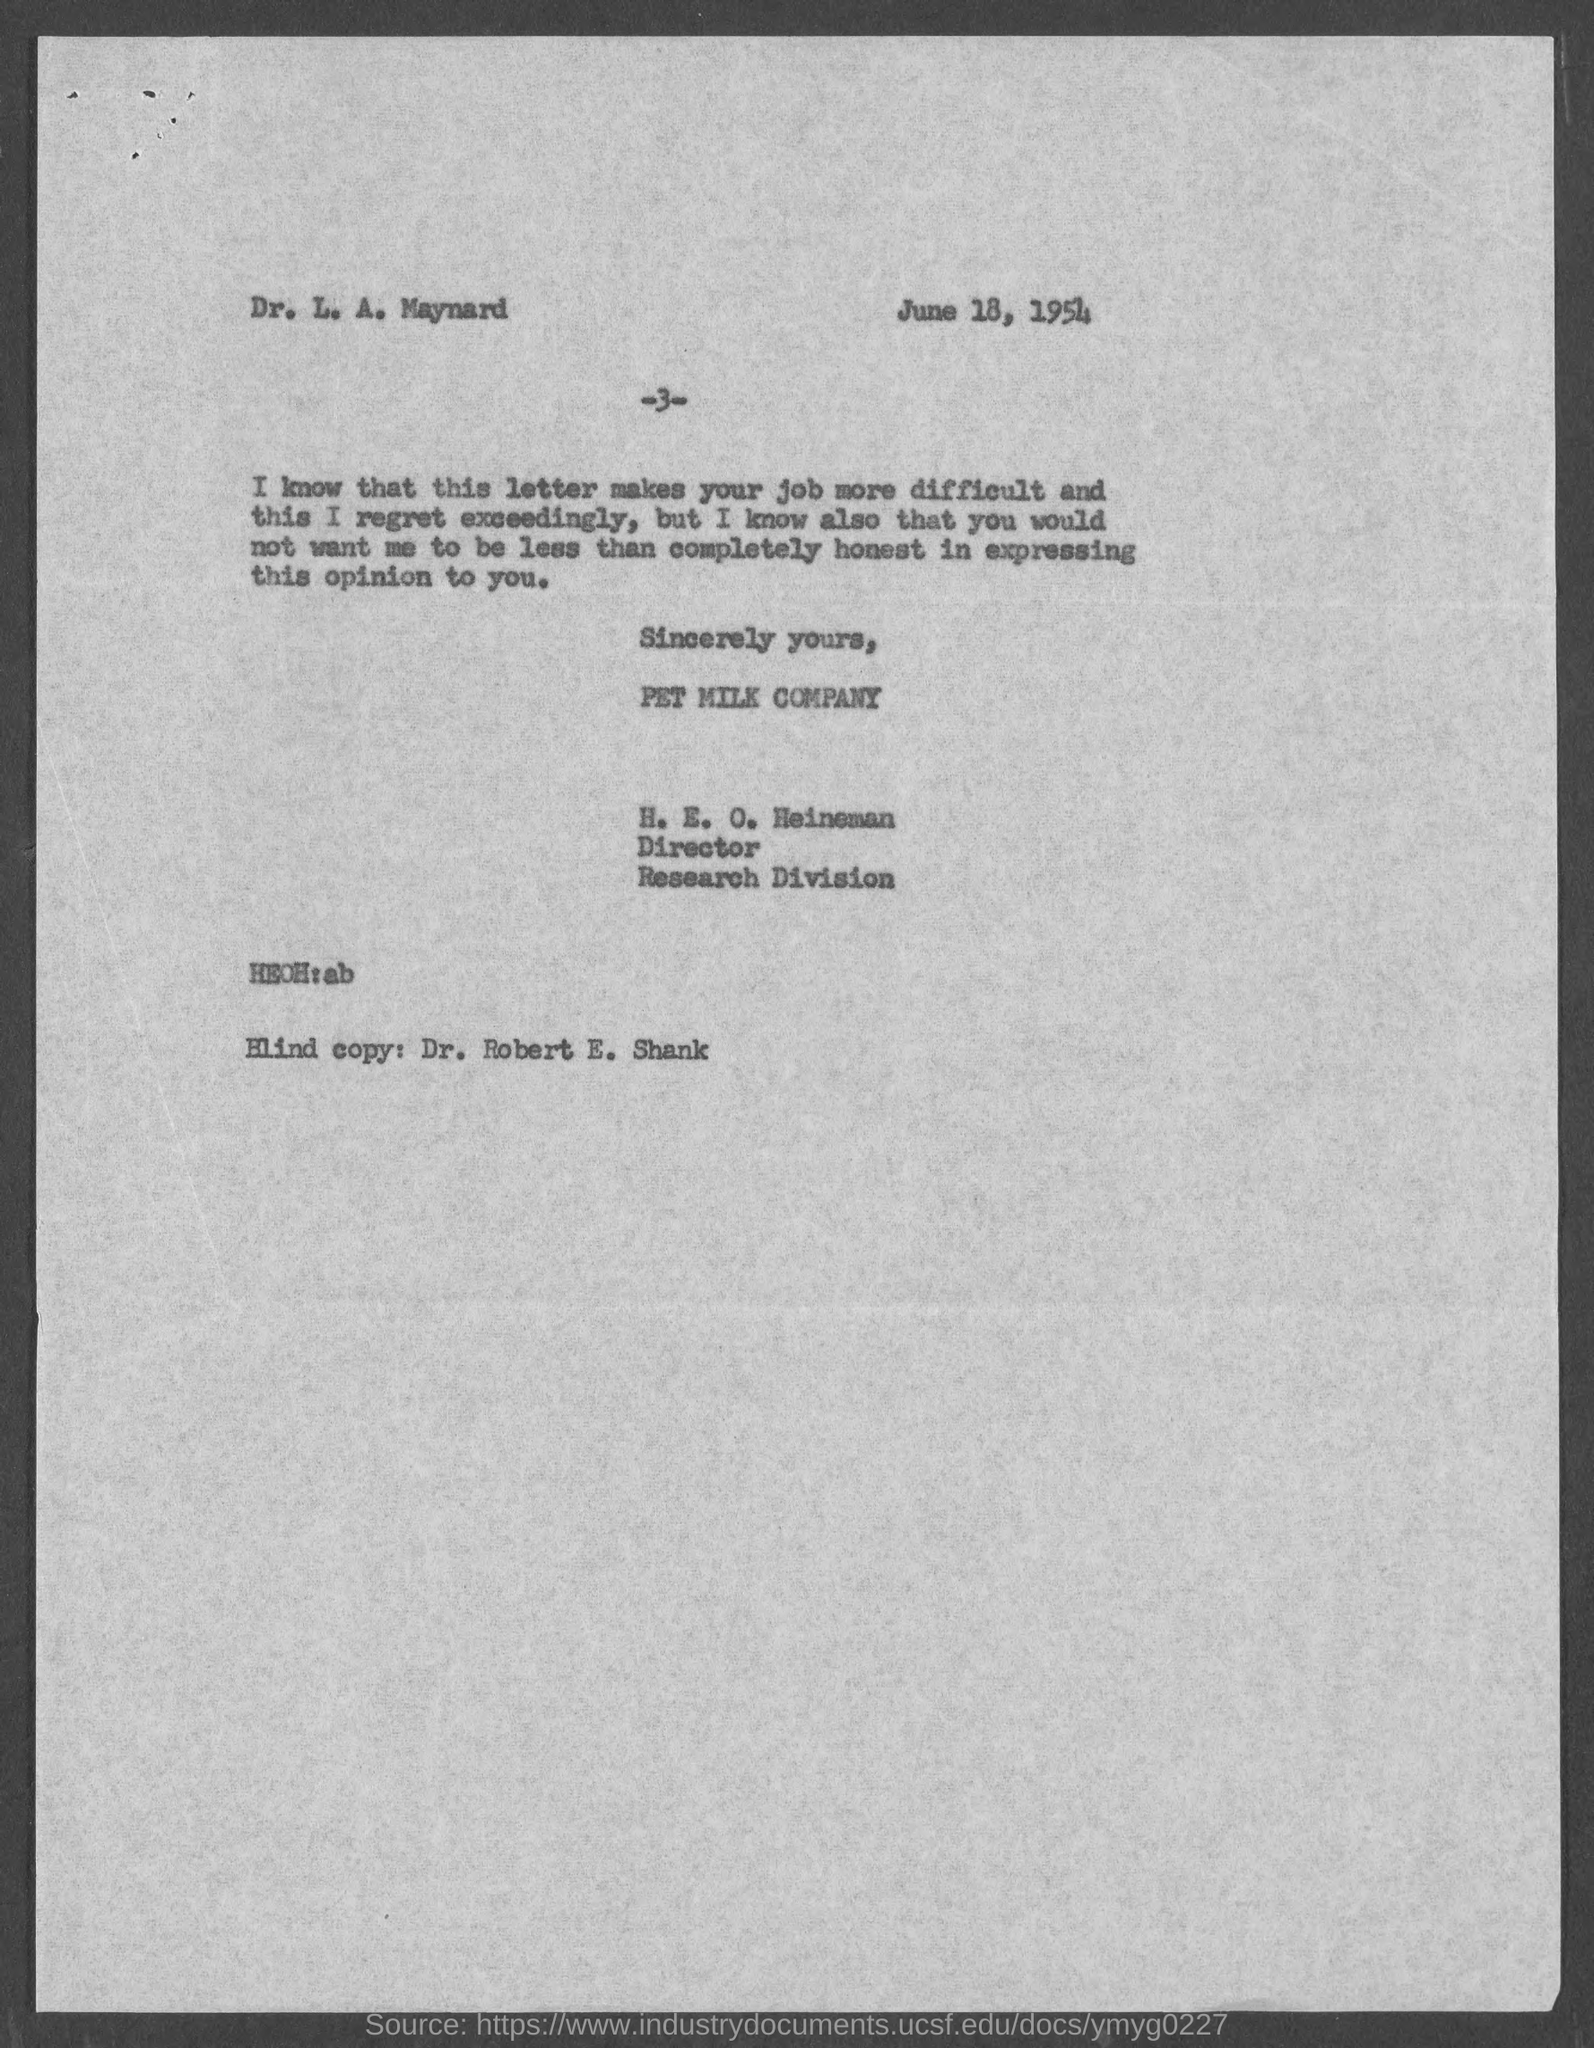The Blind copy was sent to?
Offer a terse response. Dr. Robert E. Shank. 